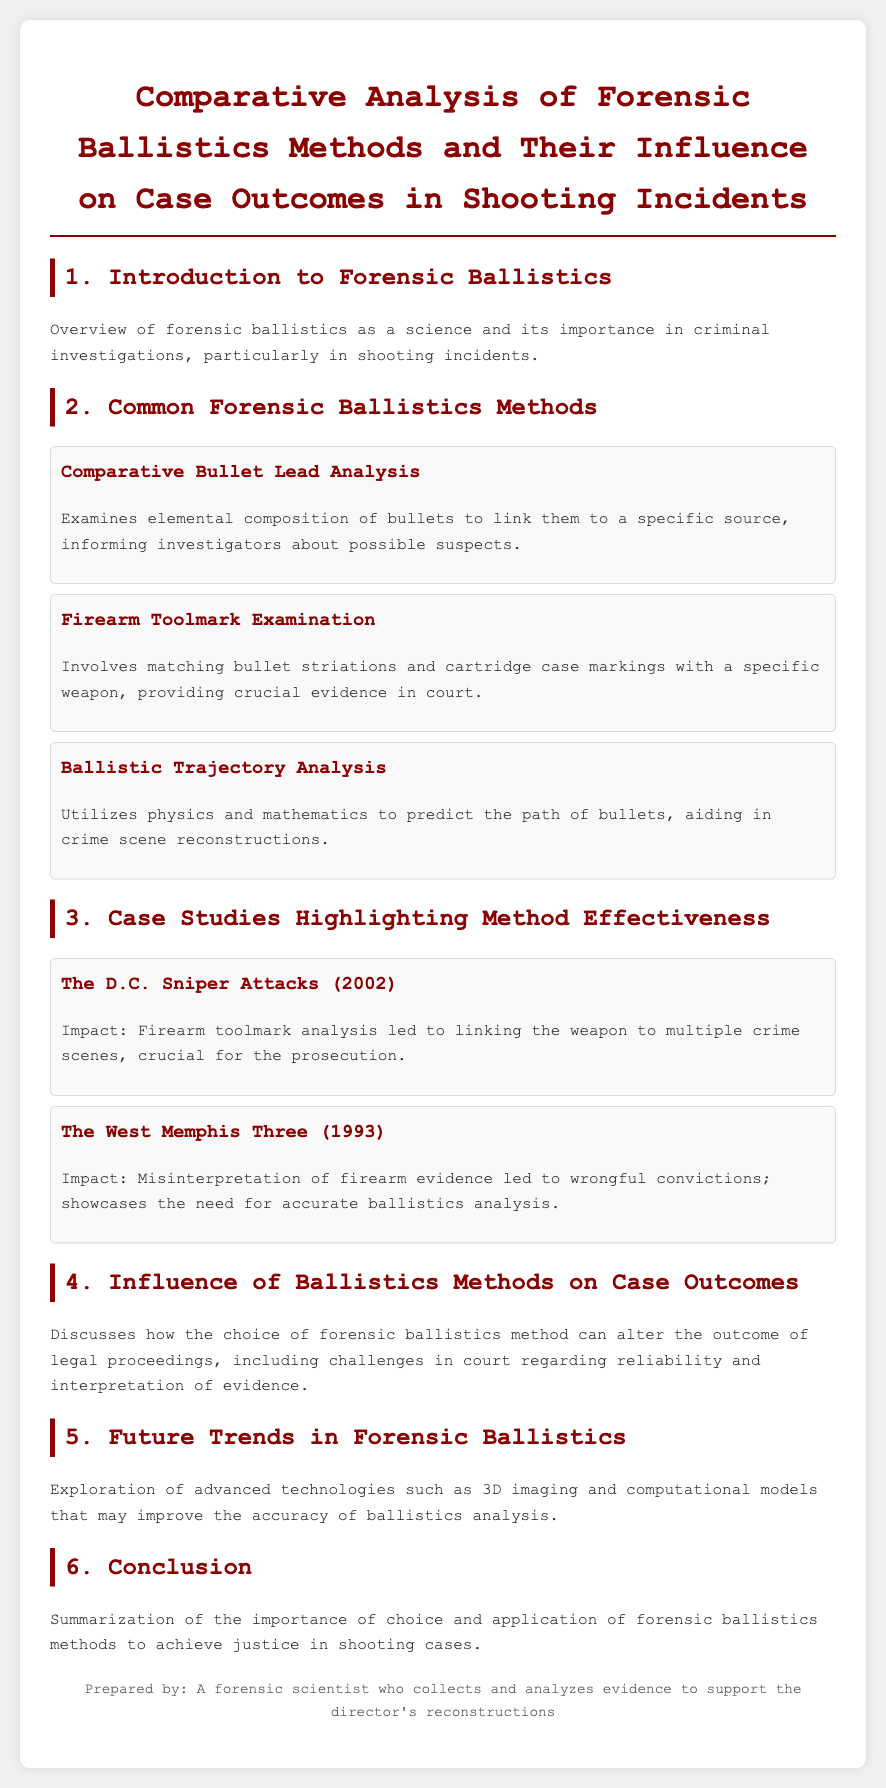What is the primary focus of the document? The document primarily focuses on forensic ballistics methods and their influence on case outcomes in shooting incidents.
Answer: Forensic ballistics methods How many common forensic ballistics methods are mentioned? The document lists three common forensic ballistics methods.
Answer: Three What method involves matching bullet striations? The method that involves matching bullet striations is noted as firearm toolmark examination.
Answer: Firearm toolmark examination Which case study highlighted wrongful convictions? The West Memphis Three case study highlighted wrongful convictions due to misinterpretation of firearm evidence.
Answer: The West Memphis Three What year did the D.C. Sniper attacks occur? The D.C. Sniper attacks occurred in the year 2002.
Answer: 2002 What future trend is explored in forensic ballistics? The document explores advanced technologies such as 3D imaging as a future trend in forensic ballistics.
Answer: 3D imaging What is a critical aspect of how ballistics methods can affect legal outcomes? The choice of forensic ballistics method can alter the outcome of legal proceedings.
Answer: Alter the outcome What does the conclusion summarize? The conclusion summarizes the importance of choice and application of forensic ballistics methods to achieve justice.
Answer: Importance of choice and application 